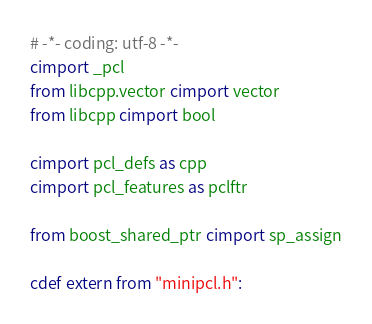Convert code to text. <code><loc_0><loc_0><loc_500><loc_500><_Cython_># -*- coding: utf-8 -*-
cimport _pcl
from libcpp.vector cimport vector
from libcpp cimport bool

cimport pcl_defs as cpp
cimport pcl_features as pclftr

from boost_shared_ptr cimport sp_assign

cdef extern from "minipcl.h":</code> 